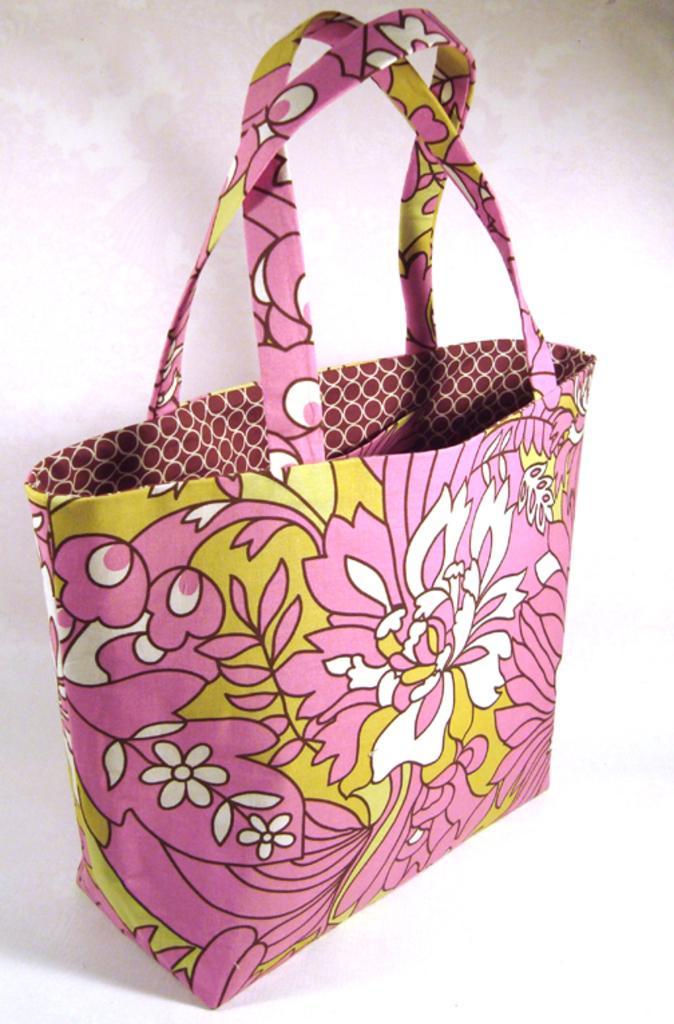Can you describe this image briefly? There is a pink color hand bag on the white color floor and the bag is of three colors white, pink and green which has same design like flowers. 